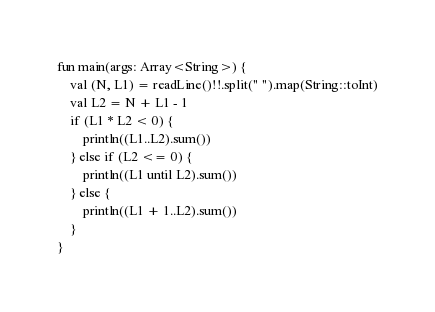<code> <loc_0><loc_0><loc_500><loc_500><_Kotlin_>fun main(args: Array<String>) {
    val (N, L1) = readLine()!!.split(" ").map(String::toInt)
    val L2 = N + L1 - 1
    if (L1 * L2 < 0) {
        println((L1..L2).sum())
    } else if (L2 <= 0) {
        println((L1 until L2).sum())
    } else {
        println((L1 + 1..L2).sum())
    }
}</code> 